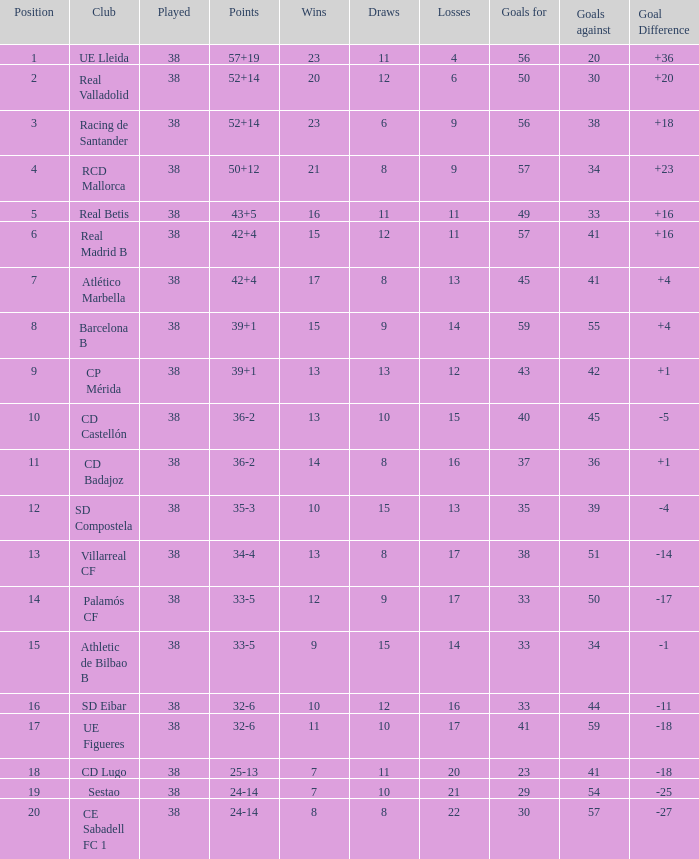Which is the largest number achieved with a goal difference of less than -27? None. 